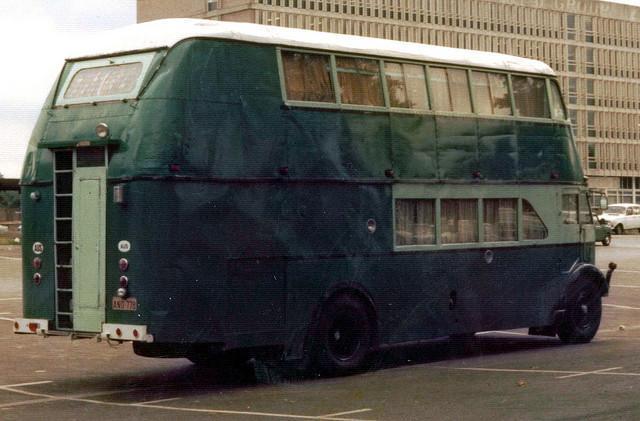How many levels is the bus?
Give a very brief answer. 2. How many stories is the bus?
Give a very brief answer. 2. 